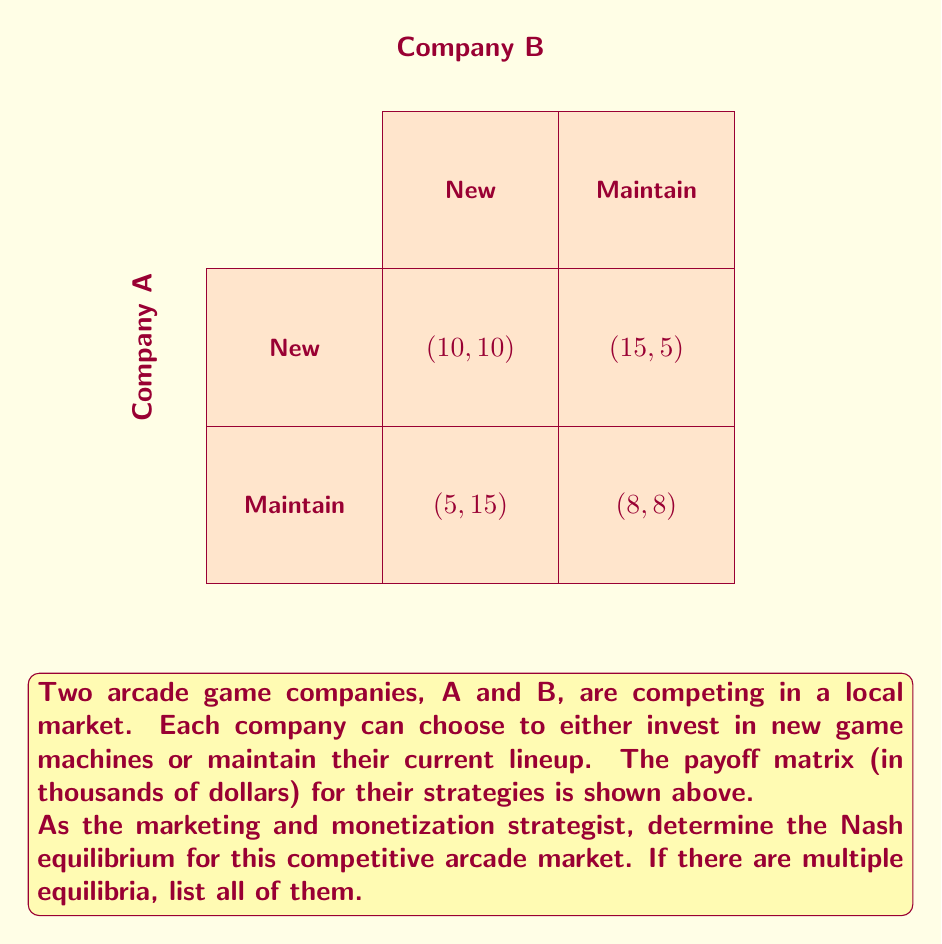Help me with this question. To find the Nash equilibrium, we need to analyze each company's best response to the other company's strategy:

1. For Company A:
   - If B chooses "New": A's best response is "New" (10 > 5)
   - If B chooses "Maintain": A's best response is "New" (15 > 8)

2. For Company B:
   - If A chooses "New": B's best response is "New" (10 > 5)
   - If A chooses "Maintain": B's best response is "New" (15 > 8)

3. Nash equilibrium occurs when both companies are playing their best responses simultaneously.

4. From the analysis, we can see that regardless of what the other company does, both Company A and Company B always prefer to choose "New".

5. Therefore, the strategy profile (New, New) is the only Nash equilibrium in this game.

6. We can verify this by checking that neither company has an incentive to unilaterally deviate from this strategy:
   - If A switches to "Maintain" while B stays at "New", A's payoff decreases from 10 to 5.
   - If B switches to "Maintain" while A stays at "New", B's payoff decreases from 10 to 5.

Thus, (New, New) is a stable strategy profile where neither player can improve their payoff by changing their strategy unilaterally, which is the definition of a Nash equilibrium.
Answer: (New, New) 